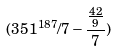Convert formula to latex. <formula><loc_0><loc_0><loc_500><loc_500>( 3 5 1 ^ { 1 8 7 } / 7 - \frac { \frac { 4 2 } { 9 } } { 7 } )</formula> 